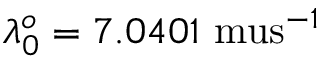Convert formula to latex. <formula><loc_0><loc_0><loc_500><loc_500>\lambda _ { 0 } ^ { o } = 7 . 0 4 0 1 \ m u s ^ { - 1 }</formula> 